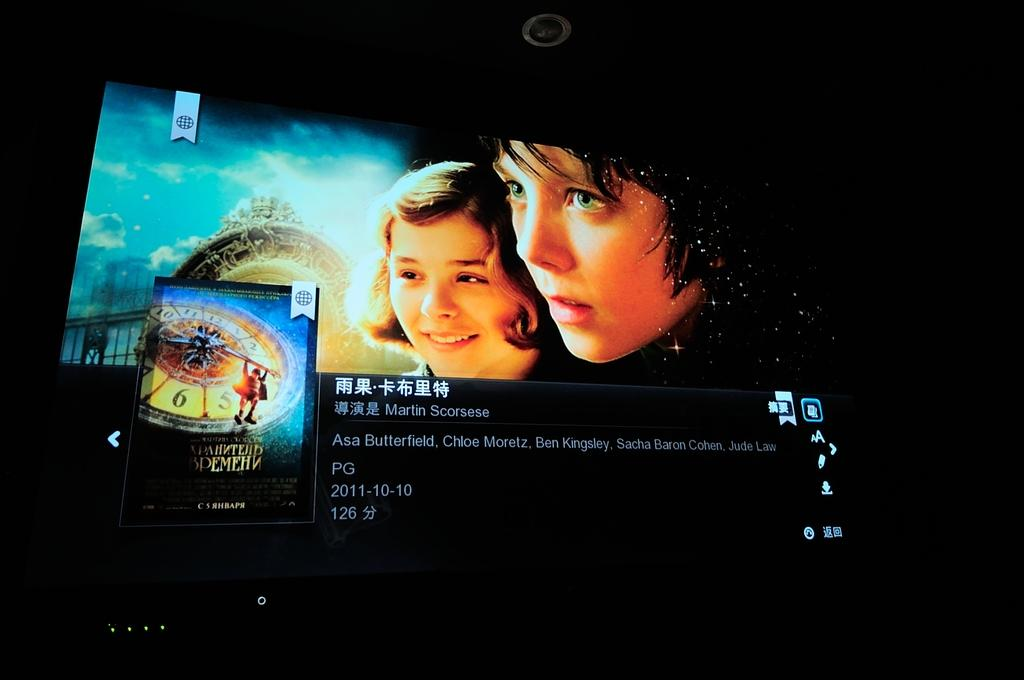What is the main object in the image? There is a screen in the image. What can be seen on the screen? Two persons' faces are visible on the screen, along with white text. What is the color of the text on the screen? The text on the screen is white. What is the background color of the screen? The background of the screen is black. Can you tell me how many islands are visible in the image? There are no islands visible in the image; it features a screen with two persons' faces and white text on a black background. What type of store is shown in the image? There is no store present in the image; it features a screen with two persons' faces and white text on a black background. 